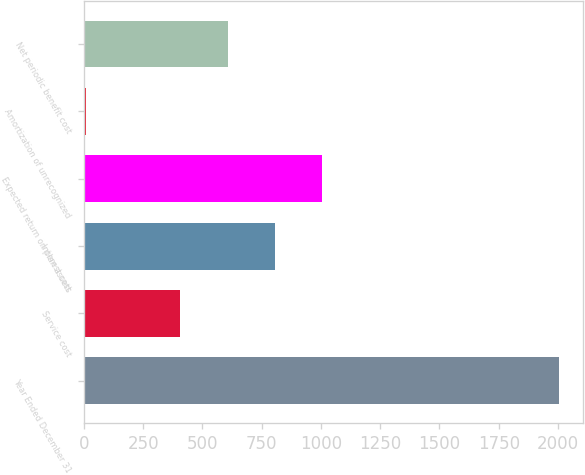<chart> <loc_0><loc_0><loc_500><loc_500><bar_chart><fcel>Year Ended December 31<fcel>Service cost<fcel>Interest cost<fcel>Expected return on plan assets<fcel>Amortization of unrecognized<fcel>Net periodic benefit cost<nl><fcel>2005<fcel>407<fcel>806.5<fcel>1006.25<fcel>7.5<fcel>606.75<nl></chart> 